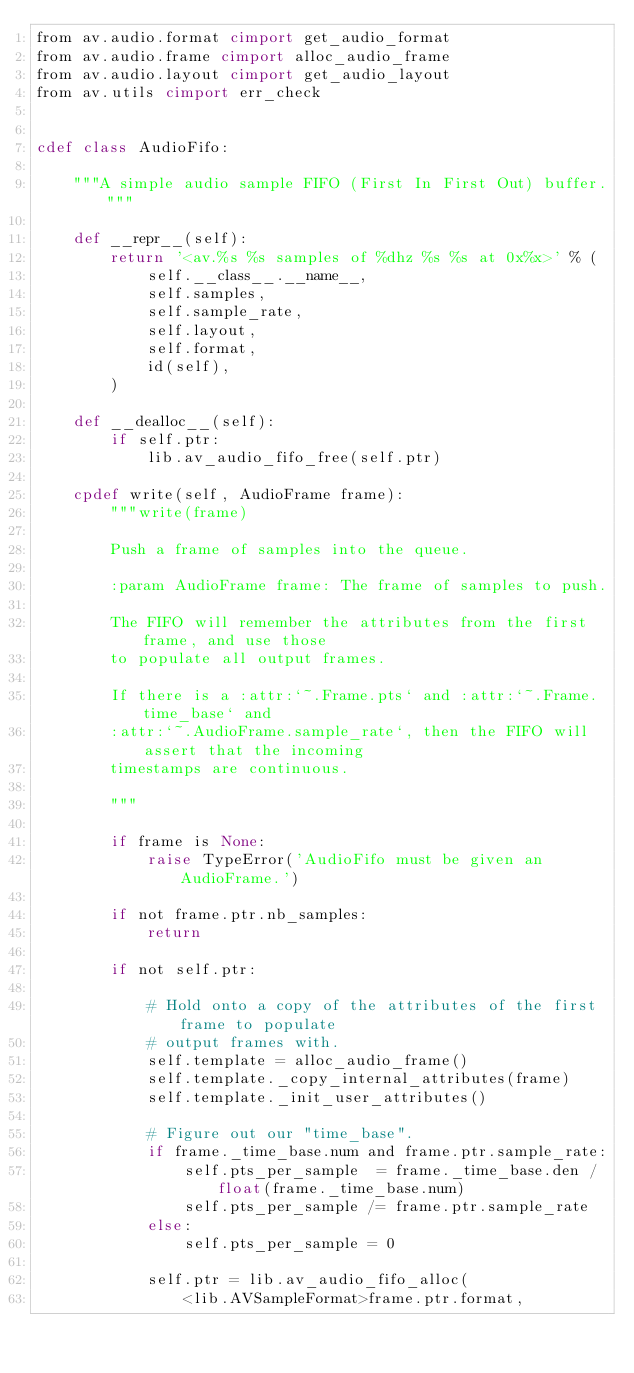Convert code to text. <code><loc_0><loc_0><loc_500><loc_500><_Cython_>from av.audio.format cimport get_audio_format
from av.audio.frame cimport alloc_audio_frame
from av.audio.layout cimport get_audio_layout
from av.utils cimport err_check


cdef class AudioFifo:

    """A simple audio sample FIFO (First In First Out) buffer."""

    def __repr__(self):
        return '<av.%s %s samples of %dhz %s %s at 0x%x>' % (
            self.__class__.__name__,
            self.samples,
            self.sample_rate,
            self.layout,
            self.format,
            id(self),
        )

    def __dealloc__(self):
        if self.ptr:
            lib.av_audio_fifo_free(self.ptr)

    cpdef write(self, AudioFrame frame):
        """write(frame)

        Push a frame of samples into the queue.

        :param AudioFrame frame: The frame of samples to push.

        The FIFO will remember the attributes from the first frame, and use those
        to populate all output frames.

        If there is a :attr:`~.Frame.pts` and :attr:`~.Frame.time_base` and
        :attr:`~.AudioFrame.sample_rate`, then the FIFO will assert that the incoming
        timestamps are continuous.

        """

        if frame is None:
            raise TypeError('AudioFifo must be given an AudioFrame.')

        if not frame.ptr.nb_samples:
            return

        if not self.ptr:

            # Hold onto a copy of the attributes of the first frame to populate
            # output frames with.
            self.template = alloc_audio_frame()
            self.template._copy_internal_attributes(frame)
            self.template._init_user_attributes()

            # Figure out our "time_base".
            if frame._time_base.num and frame.ptr.sample_rate:
                self.pts_per_sample  = frame._time_base.den / float(frame._time_base.num)
                self.pts_per_sample /= frame.ptr.sample_rate
            else:
                self.pts_per_sample = 0

            self.ptr = lib.av_audio_fifo_alloc(
                <lib.AVSampleFormat>frame.ptr.format,</code> 